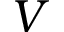Convert formula to latex. <formula><loc_0><loc_0><loc_500><loc_500>V</formula> 